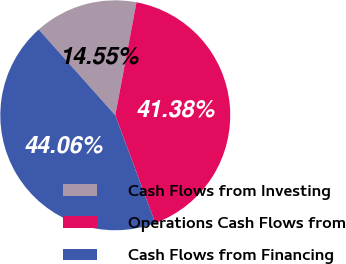Convert chart. <chart><loc_0><loc_0><loc_500><loc_500><pie_chart><fcel>Cash Flows from Investing<fcel>Operations Cash Flows from<fcel>Cash Flows from Financing<nl><fcel>14.55%<fcel>41.38%<fcel>44.06%<nl></chart> 